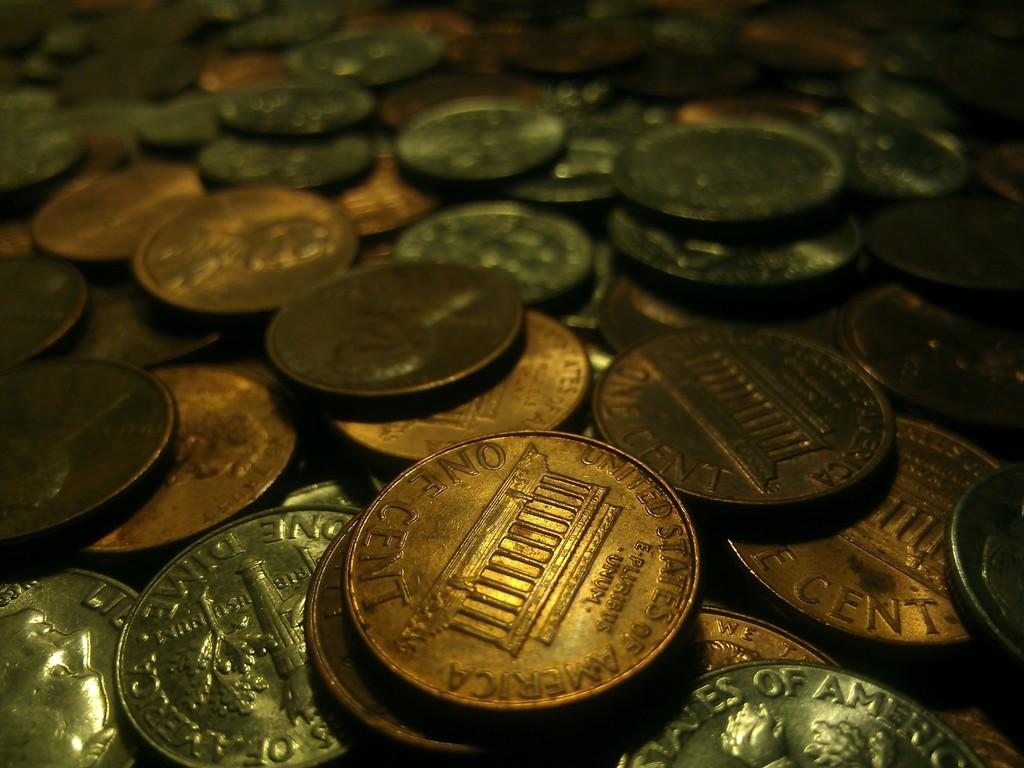Provide a one-sentence caption for the provided image. Pennies and dimes are among the large collection of coins. 